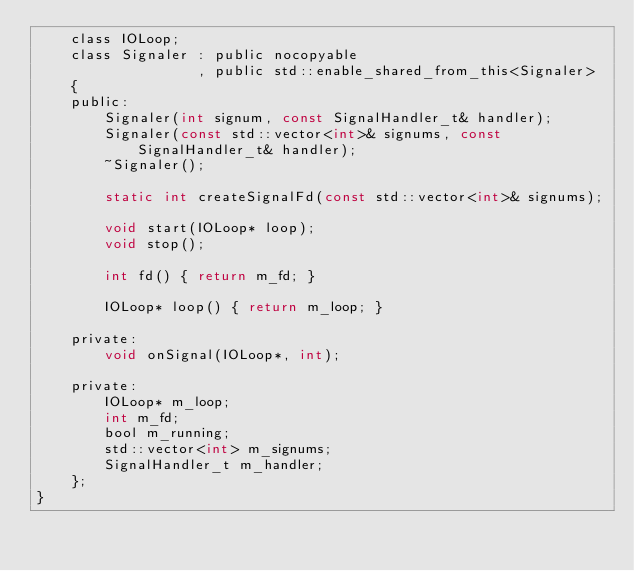Convert code to text. <code><loc_0><loc_0><loc_500><loc_500><_C_>    class IOLoop;
    class Signaler : public nocopyable
                   , public std::enable_shared_from_this<Signaler>
    {
    public:
        Signaler(int signum, const SignalHandler_t& handler);
        Signaler(const std::vector<int>& signums, const SignalHandler_t& handler);
        ~Signaler();

        static int createSignalFd(const std::vector<int>& signums);

        void start(IOLoop* loop);
        void stop();

        int fd() { return m_fd; }

        IOLoop* loop() { return m_loop; }

    private:
        void onSignal(IOLoop*, int);

    private:
        IOLoop* m_loop;
        int m_fd;
        bool m_running;
        std::vector<int> m_signums;
        SignalHandler_t m_handler;
    };    
}
</code> 